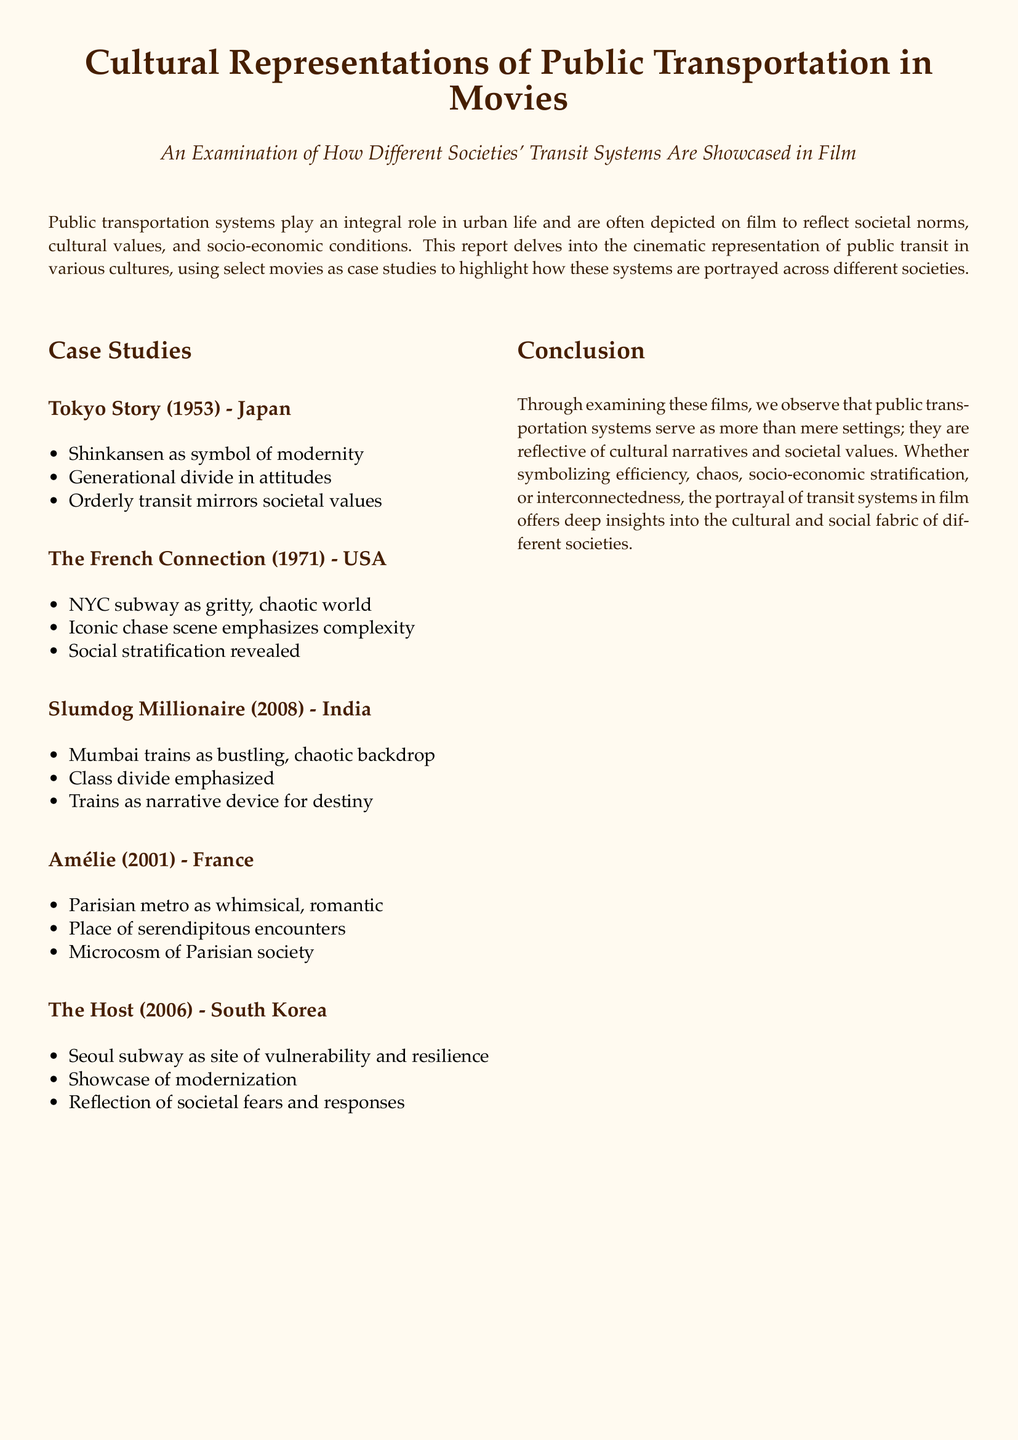What is the title of the report? The title is prominently displayed at the beginning of the document, highlighting the focus on cultural representations.
Answer: Cultural Representations of Public Transportation in Movies Which case study film represents Japan? The document lists specific films along with their corresponding countries, with Tokyo Story showcasing Japan.
Answer: Tokyo Story What year was The French Connection released? The date provided in the case studies section notes the release year of the film in the United States.
Answer: 1971 What does the Shinkansen symbolize in Tokyo Story? Information in the report specifies that the Shinkansen symbolizes modernity in the context of the film.
Answer: modernity In which movie are the Mumbai trains depicted as bustling? The report indicates that Slumdog Millionaire features the Mumbai trains as a prominent setting.
Answer: Slumdog Millionaire What societal aspect does the NYC subway emphasize in The French Connection? The document mentions that the NYC subway highlights social stratification within the film.
Answer: social stratification Which public transportation system is showcased in The Host? The case studies list the Seoul subway as a significant element in the portrayal of South Korean society in the film.
Answer: Seoul subway What thematic role do trains play in Slumdog Millionaire? The film uses trains as a narrative device that emphasizes destiny, a point made in the case study.
Answer: narrative device for destiny What city is the Parisian metro associated with in Amélie? The report explicitly associates the Parisian metro with the city of Paris in the context of the film.
Answer: Paris 